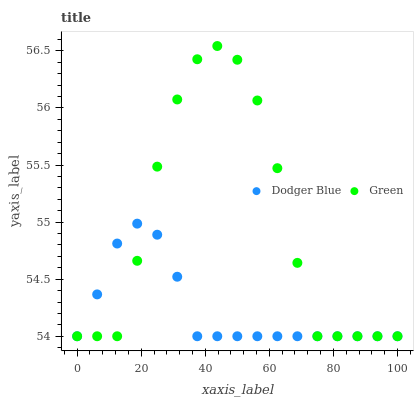Does Dodger Blue have the minimum area under the curve?
Answer yes or no. Yes. Does Green have the maximum area under the curve?
Answer yes or no. Yes. Does Dodger Blue have the maximum area under the curve?
Answer yes or no. No. Is Dodger Blue the smoothest?
Answer yes or no. Yes. Is Green the roughest?
Answer yes or no. Yes. Is Dodger Blue the roughest?
Answer yes or no. No. Does Green have the lowest value?
Answer yes or no. Yes. Does Green have the highest value?
Answer yes or no. Yes. Does Dodger Blue have the highest value?
Answer yes or no. No. Does Green intersect Dodger Blue?
Answer yes or no. Yes. Is Green less than Dodger Blue?
Answer yes or no. No. Is Green greater than Dodger Blue?
Answer yes or no. No. 